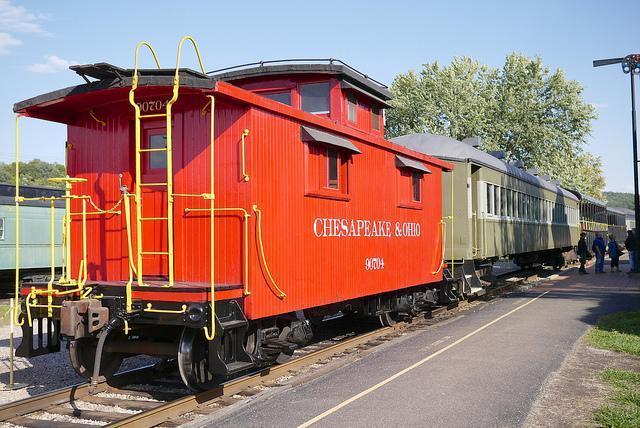How many people are shown?
Give a very brief answer. 4. 